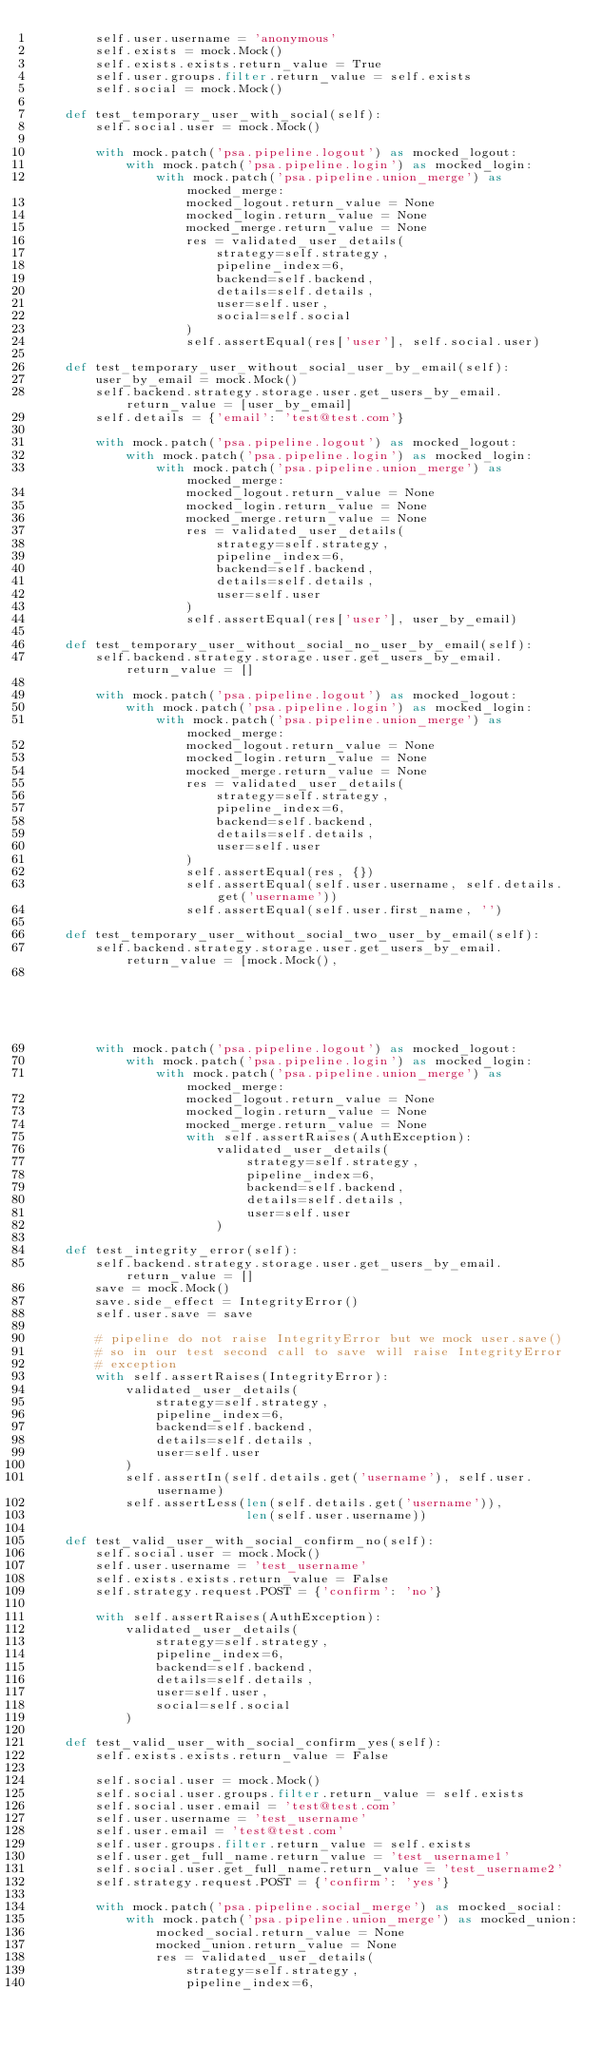<code> <loc_0><loc_0><loc_500><loc_500><_Python_>        self.user.username = 'anonymous'
        self.exists = mock.Mock()
        self.exists.exists.return_value = True
        self.user.groups.filter.return_value = self.exists
        self.social = mock.Mock()

    def test_temporary_user_with_social(self):
        self.social.user = mock.Mock()

        with mock.patch('psa.pipeline.logout') as mocked_logout:
            with mock.patch('psa.pipeline.login') as mocked_login:
                with mock.patch('psa.pipeline.union_merge') as mocked_merge:
                    mocked_logout.return_value = None
                    mocked_login.return_value = None
                    mocked_merge.return_value = None
                    res = validated_user_details(
                        strategy=self.strategy,
                        pipeline_index=6,
                        backend=self.backend,
                        details=self.details,
                        user=self.user,
                        social=self.social
                    )
                    self.assertEqual(res['user'], self.social.user)

    def test_temporary_user_without_social_user_by_email(self):
        user_by_email = mock.Mock()
        self.backend.strategy.storage.user.get_users_by_email.return_value = [user_by_email]
        self.details = {'email': 'test@test.com'}

        with mock.patch('psa.pipeline.logout') as mocked_logout:
            with mock.patch('psa.pipeline.login') as mocked_login:
                with mock.patch('psa.pipeline.union_merge') as mocked_merge:
                    mocked_logout.return_value = None
                    mocked_login.return_value = None
                    mocked_merge.return_value = None
                    res = validated_user_details(
                        strategy=self.strategy,
                        pipeline_index=6,
                        backend=self.backend,
                        details=self.details,
                        user=self.user
                    )
                    self.assertEqual(res['user'], user_by_email)

    def test_temporary_user_without_social_no_user_by_email(self):
        self.backend.strategy.storage.user.get_users_by_email.return_value = []

        with mock.patch('psa.pipeline.logout') as mocked_logout:
            with mock.patch('psa.pipeline.login') as mocked_login:
                with mock.patch('psa.pipeline.union_merge') as mocked_merge:
                    mocked_logout.return_value = None
                    mocked_login.return_value = None
                    mocked_merge.return_value = None
                    res = validated_user_details(
                        strategy=self.strategy,
                        pipeline_index=6,
                        backend=self.backend,
                        details=self.details,
                        user=self.user
                    )
                    self.assertEqual(res, {})
                    self.assertEqual(self.user.username, self.details.get('username'))
                    self.assertEqual(self.user.first_name, '')

    def test_temporary_user_without_social_two_user_by_email(self):
        self.backend.strategy.storage.user.get_users_by_email.return_value = [mock.Mock(),
                                                                              mock.Mock()]
        with mock.patch('psa.pipeline.logout') as mocked_logout:
            with mock.patch('psa.pipeline.login') as mocked_login:
                with mock.patch('psa.pipeline.union_merge') as mocked_merge:
                    mocked_logout.return_value = None
                    mocked_login.return_value = None
                    mocked_merge.return_value = None
                    with self.assertRaises(AuthException):
                        validated_user_details(
                            strategy=self.strategy,
                            pipeline_index=6,
                            backend=self.backend,
                            details=self.details,
                            user=self.user
                        )

    def test_integrity_error(self):
        self.backend.strategy.storage.user.get_users_by_email.return_value = []
        save = mock.Mock()
        save.side_effect = IntegrityError()
        self.user.save = save

        # pipeline do not raise IntegrityError but we mock user.save()
        # so in our test second call to save will raise IntegrityError
        # exception
        with self.assertRaises(IntegrityError):
            validated_user_details(
                strategy=self.strategy,
                pipeline_index=6,
                backend=self.backend,
                details=self.details,
                user=self.user
            )
            self.assertIn(self.details.get('username'), self.user.username)
            self.assertLess(len(self.details.get('username')),
                            len(self.user.username))

    def test_valid_user_with_social_confirm_no(self):
        self.social.user = mock.Mock()
        self.user.username = 'test_username'
        self.exists.exists.return_value = False
        self.strategy.request.POST = {'confirm': 'no'}

        with self.assertRaises(AuthException):
            validated_user_details(
                strategy=self.strategy,
                pipeline_index=6,
                backend=self.backend,
                details=self.details,
                user=self.user,
                social=self.social
            )

    def test_valid_user_with_social_confirm_yes(self):
        self.exists.exists.return_value = False

        self.social.user = mock.Mock()
        self.social.user.groups.filter.return_value = self.exists
        self.social.user.email = 'test@test.com'
        self.user.username = 'test_username'
        self.user.email = 'test@test.com'
        self.user.groups.filter.return_value = self.exists
        self.user.get_full_name.return_value = 'test_username1'
        self.social.user.get_full_name.return_value = 'test_username2'
        self.strategy.request.POST = {'confirm': 'yes'}

        with mock.patch('psa.pipeline.social_merge') as mocked_social:
            with mock.patch('psa.pipeline.union_merge') as mocked_union:
                mocked_social.return_value = None
                mocked_union.return_value = None
                res = validated_user_details(
                    strategy=self.strategy,
                    pipeline_index=6,</code> 